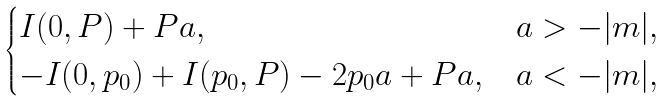<formula> <loc_0><loc_0><loc_500><loc_500>\begin{cases} I ( 0 , P ) + P a , & a > - | m | , \\ - I ( 0 , p _ { 0 } ) + I ( p _ { 0 } , P ) - 2 p _ { 0 } a + P a , & a < - | m | , \end{cases}</formula> 